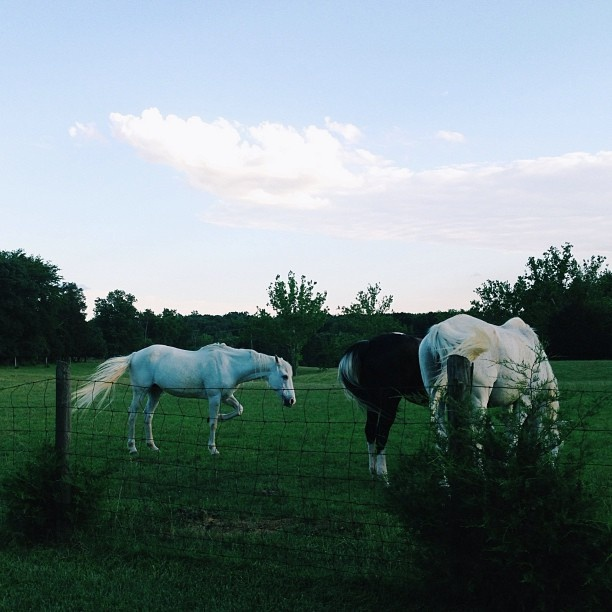Describe the objects in this image and their specific colors. I can see horse in lightblue, black, darkgray, and teal tones, horse in lightblue, teal, darkgray, and black tones, and horse in lightblue, black, teal, and darkgreen tones in this image. 